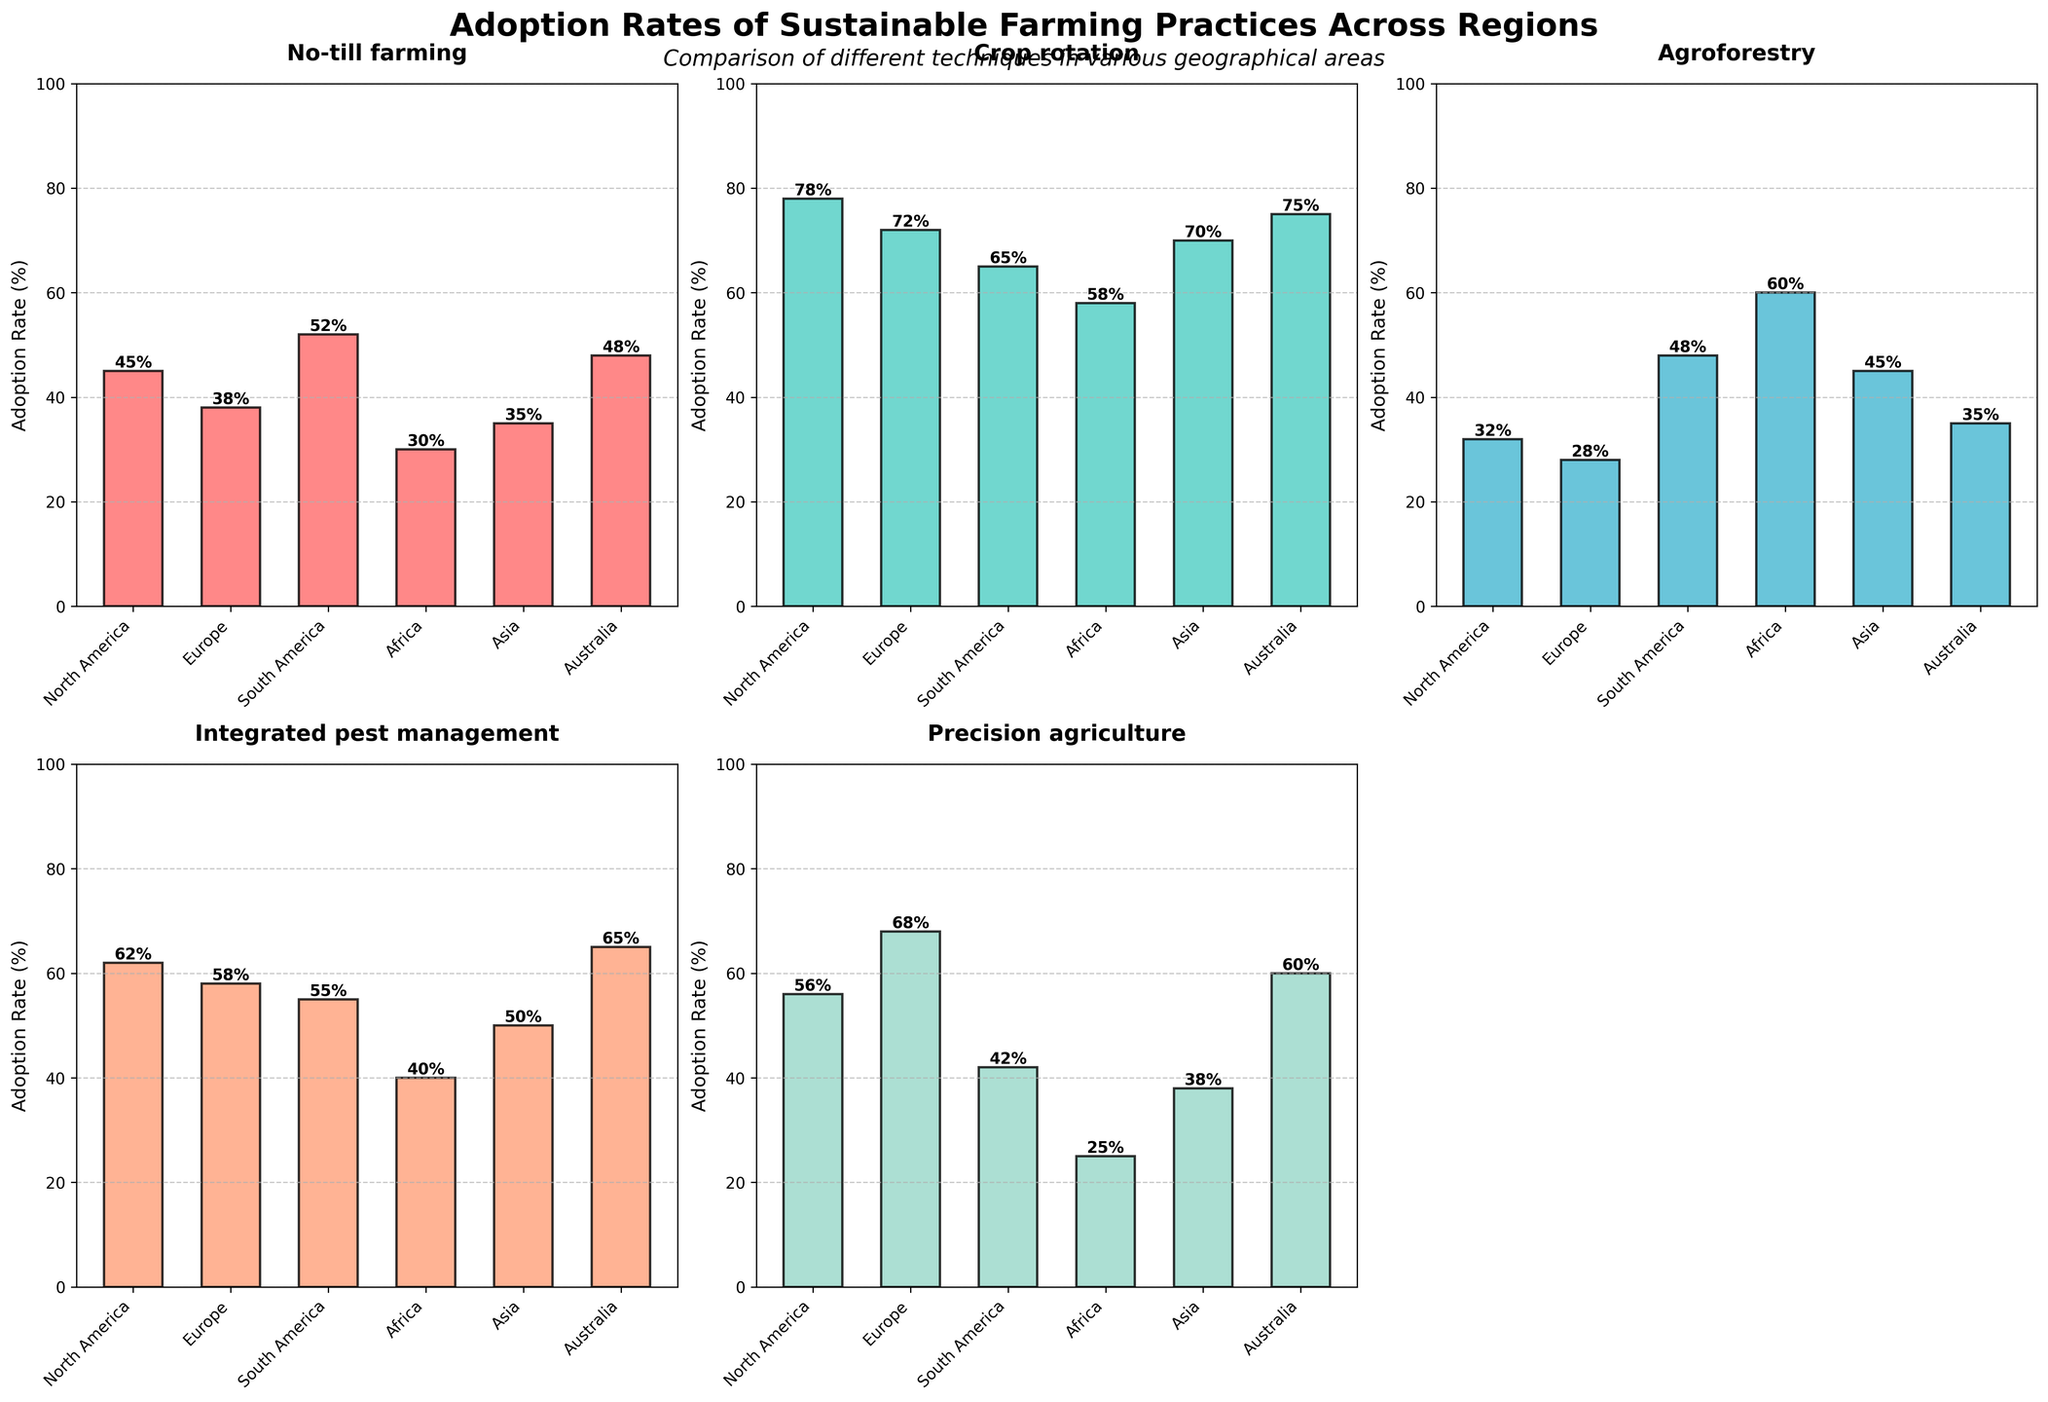What is the title of the figure? The main title is displayed at the top of the figure and is usually in bold font. In this case, it reads as the summary of the plot itself.
Answer: Adoption Rates of Sustainable Farming Practices Across Regions Which region has the highest adoption rate for No-till farming? For No-till farming, the subplot shows North America having the highest bar reaching up to 45%.
Answer: North America How does the adoption rate of Integrated pest management in South America compare to that in Australia? In the subplot for Integrated pest management, the bar for South America reaches 55%, whereas the bar for Australia is slightly higher at 65%.
Answer: Australia is higher What is the difference in adoption rates for Agroforestry between Africa and North America? The bar for Agroforestry in Africa is at 60%, while that in North America stands at 32%. Subtracting the smaller percentage from the larger gives a difference of 28%.
Answer: 28% Which farming practice has the lowest adoption rate in Asia? By observing the heights of the bars in each subplot for Asia, Precision agriculture has the lowest adoption rate at 38%.
Answer: Precision agriculture Which two regions have the closest adoption rates for Crop rotation? Looking at the subplot for Crop rotation, North America has a rate of 78% and Australia has a rate of 75%, which are the closest among all regions.
Answer: North America and Australia What is the average adoption rate of Precision agriculture across all regions? Adding the adoption rates for Precision agriculture (North America: 56%, Europe: 68%, South America: 42%, Africa: 25%, Asia: 38%, Australia: 60%) gives a total of 289%. Dividing this by the 6 regions results in an average of approximately 48.2%.
Answer: 48.2% Which region shows the highest variability in adoption rates across the five practices? By comparing the ranges (max - min) of adoption rates in each region: North America (78-32=46), Europe (72-28=44), South America (65-42=23), Africa (60-25=35), Asia (70-38=32), Australia (75-35=40). North America has the highest range of 46.
Answer: North America What is the combined adoption rate for No-till farming and Crop rotation in Europe? In Europe, No-till farming has an adoption rate of 38% and Crop rotation has 72%. Adding these two rates gives 110%.
Answer: 110% 